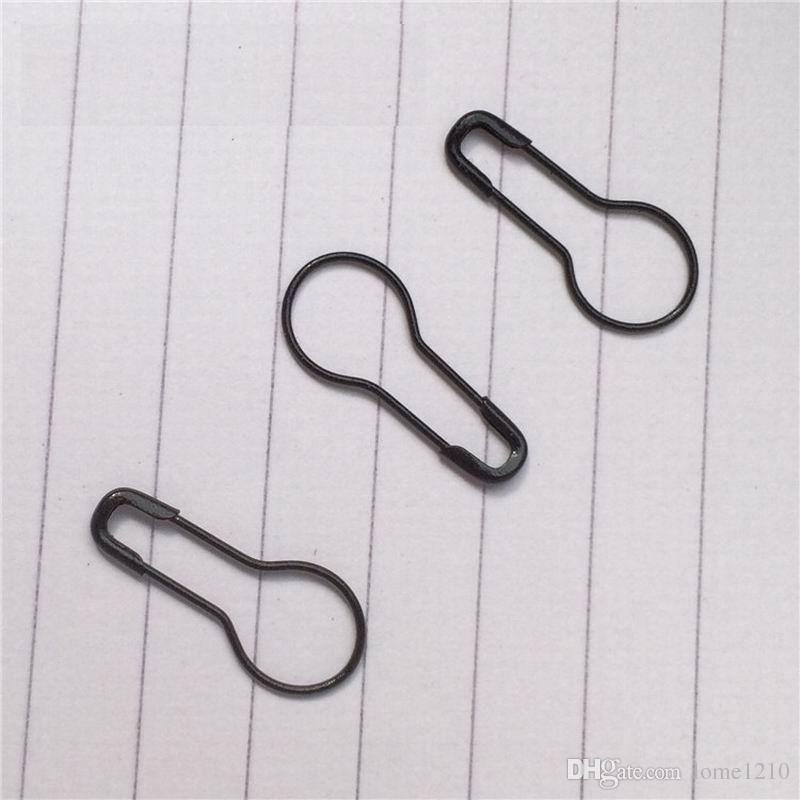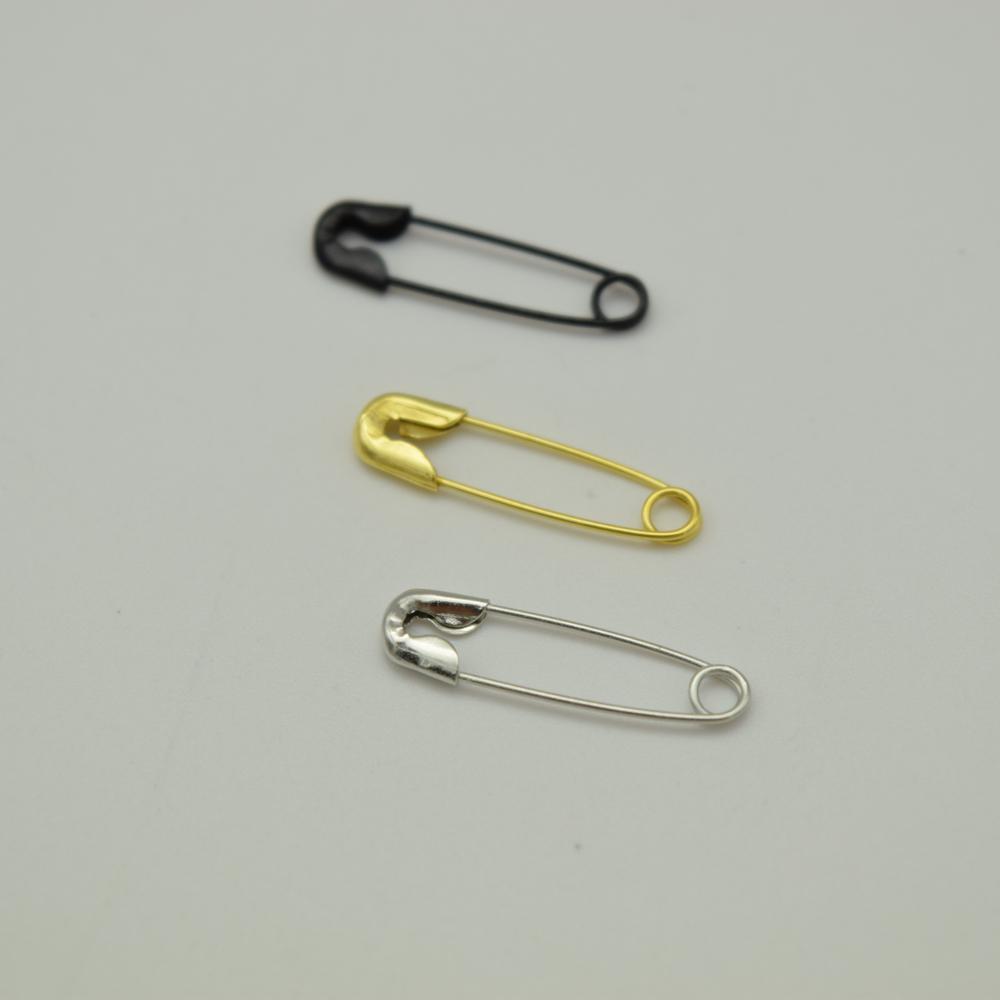The first image is the image on the left, the second image is the image on the right. Examine the images to the left and right. Is the description "There are six paperclips total." accurate? Answer yes or no. Yes. 